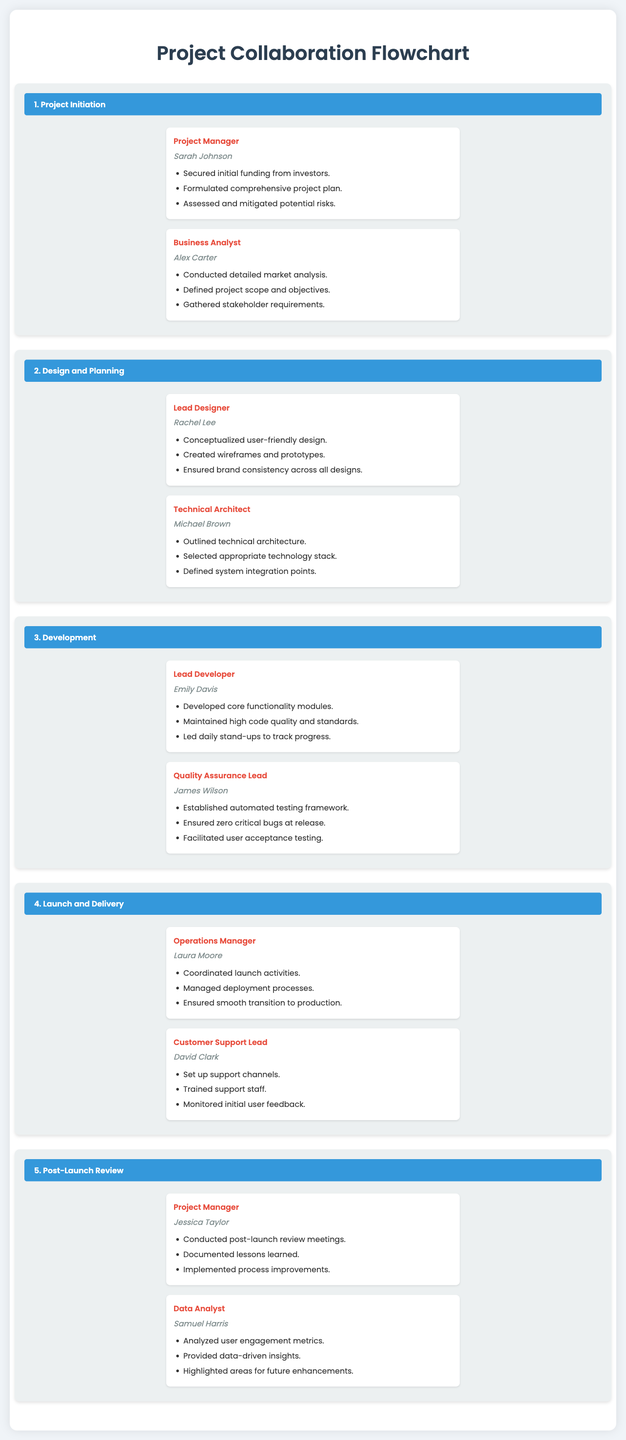What is the title of the document? The title of the document is prominently displayed at the top, indicating the theme of the content.
Answer: Project Collaboration Flowchart Who is the Project Manager during the Project Initiation phase? The document lists the individuals responsible for various roles, including that of the Project Manager for the initial phase.
Answer: Sarah Johnson What role does Rachel Lee have? Rachel Lee is mentioned within a section of the document indicating her specific responsibilities and contributions.
Answer: Lead Designer How many roles are listed under the Launch and Delivery section? The number of individuals and their roles can be determined by counting the entries in that section of the document.
Answer: 2 Which title has the name Michael Brown associated with it? The roles and names are paired throughout the document, allowing for easy retrieval of corresponding titles.
Answer: Technical Architect What key activity does the Quality Assurance Lead ensure before release? The specific responsibilities of the Quality Assurance Lead are outlined clearly, reflecting a key focus area.
Answer: Zero critical bugs During which phase is user feedback monitored? The document clearly identifies the focus areas for each phase, including aspects such as user feedback.
Answer: Launch and Delivery What are the key metrics analyzed by Samuel Harris? The analysis focus is outlined under the role of Data Analyst, detailing what metrics are significant to examine.
Answer: User engagement metrics What improvement action does Jessica Taylor take after the review? The document specifies what procedures are implemented following reviews, highlighting actions taken per role.
Answer: Process improvements 